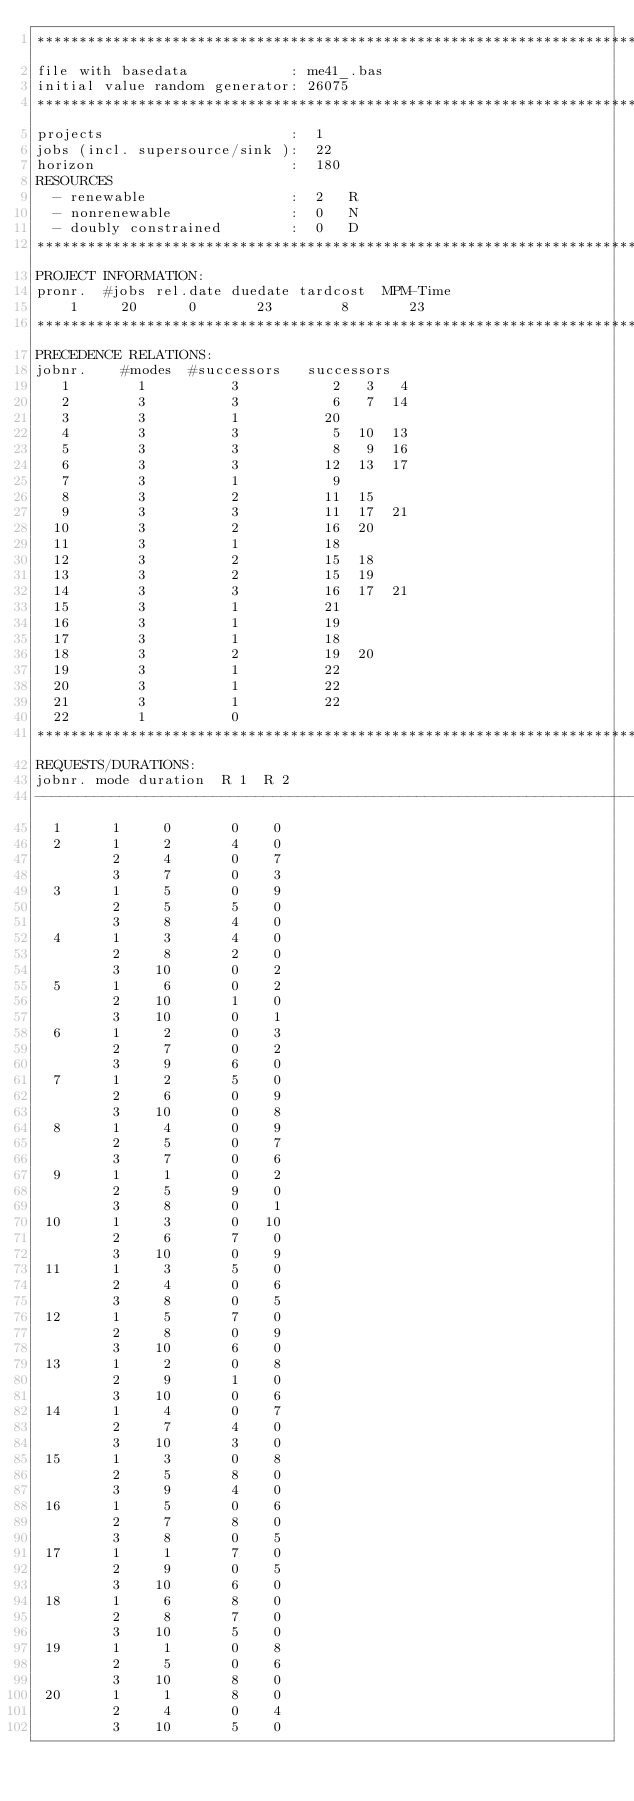Convert code to text. <code><loc_0><loc_0><loc_500><loc_500><_ObjectiveC_>************************************************************************
file with basedata            : me41_.bas
initial value random generator: 26075
************************************************************************
projects                      :  1
jobs (incl. supersource/sink ):  22
horizon                       :  180
RESOURCES
  - renewable                 :  2   R
  - nonrenewable              :  0   N
  - doubly constrained        :  0   D
************************************************************************
PROJECT INFORMATION:
pronr.  #jobs rel.date duedate tardcost  MPM-Time
    1     20      0       23        8       23
************************************************************************
PRECEDENCE RELATIONS:
jobnr.    #modes  #successors   successors
   1        1          3           2   3   4
   2        3          3           6   7  14
   3        3          1          20
   4        3          3           5  10  13
   5        3          3           8   9  16
   6        3          3          12  13  17
   7        3          1           9
   8        3          2          11  15
   9        3          3          11  17  21
  10        3          2          16  20
  11        3          1          18
  12        3          2          15  18
  13        3          2          15  19
  14        3          3          16  17  21
  15        3          1          21
  16        3          1          19
  17        3          1          18
  18        3          2          19  20
  19        3          1          22
  20        3          1          22
  21        3          1          22
  22        1          0        
************************************************************************
REQUESTS/DURATIONS:
jobnr. mode duration  R 1  R 2
------------------------------------------------------------------------
  1      1     0       0    0
  2      1     2       4    0
         2     4       0    7
         3     7       0    3
  3      1     5       0    9
         2     5       5    0
         3     8       4    0
  4      1     3       4    0
         2     8       2    0
         3    10       0    2
  5      1     6       0    2
         2    10       1    0
         3    10       0    1
  6      1     2       0    3
         2     7       0    2
         3     9       6    0
  7      1     2       5    0
         2     6       0    9
         3    10       0    8
  8      1     4       0    9
         2     5       0    7
         3     7       0    6
  9      1     1       0    2
         2     5       9    0
         3     8       0    1
 10      1     3       0   10
         2     6       7    0
         3    10       0    9
 11      1     3       5    0
         2     4       0    6
         3     8       0    5
 12      1     5       7    0
         2     8       0    9
         3    10       6    0
 13      1     2       0    8
         2     9       1    0
         3    10       0    6
 14      1     4       0    7
         2     7       4    0
         3    10       3    0
 15      1     3       0    8
         2     5       8    0
         3     9       4    0
 16      1     5       0    6
         2     7       8    0
         3     8       0    5
 17      1     1       7    0
         2     9       0    5
         3    10       6    0
 18      1     6       8    0
         2     8       7    0
         3    10       5    0
 19      1     1       0    8
         2     5       0    6
         3    10       8    0
 20      1     1       8    0
         2     4       0    4
         3    10       5    0</code> 